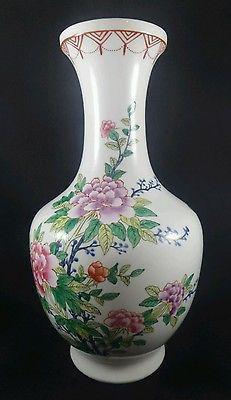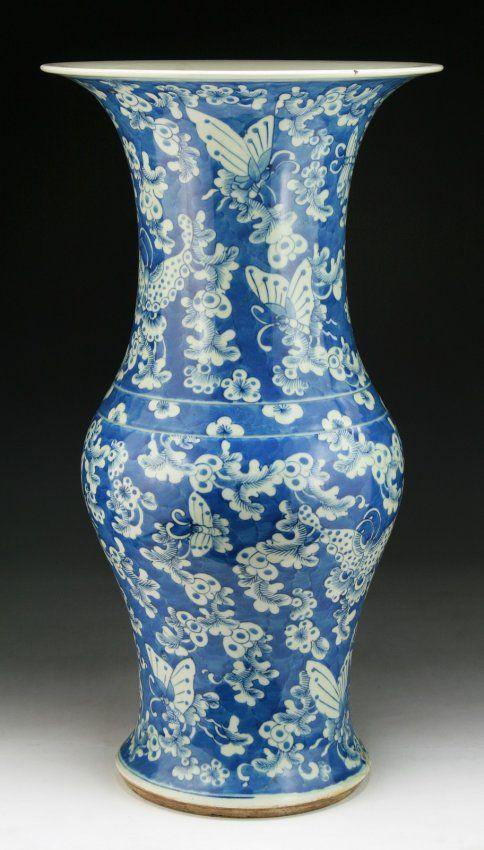The first image is the image on the left, the second image is the image on the right. Analyze the images presented: Is the assertion "In at least one image there is a all blue and white vase with a circular middle." valid? Answer yes or no. Yes. The first image is the image on the left, the second image is the image on the right. Evaluate the accuracy of this statement regarding the images: "One ceramic vase features floral motifs and only blue and white colors, and the other vase has a narrow neck with a wider round bottom and includes pink flowers as decoration.". Is it true? Answer yes or no. Yes. 